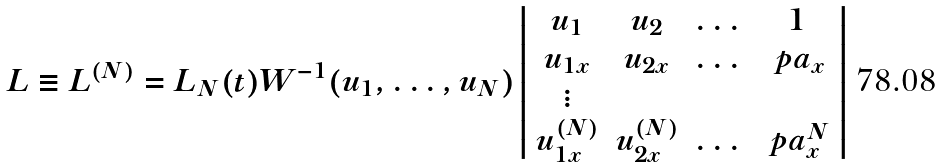Convert formula to latex. <formula><loc_0><loc_0><loc_500><loc_500>L \equiv L ^ { ( N ) } = L _ { N } ( t ) W ^ { - 1 } ( u _ { 1 } , \dots , u _ { N } ) \left | \begin{array} { c c c c } u _ { 1 } & u _ { 2 } & \dots & 1 \\ u _ { 1 x } & u _ { 2 x } & \dots & \ p a _ { x } \\ \vdots \\ u _ { 1 x } ^ { ( N ) } & u _ { 2 x } ^ { ( N ) } & \dots & \ p a _ { x } ^ { N } \end{array} \right |</formula> 